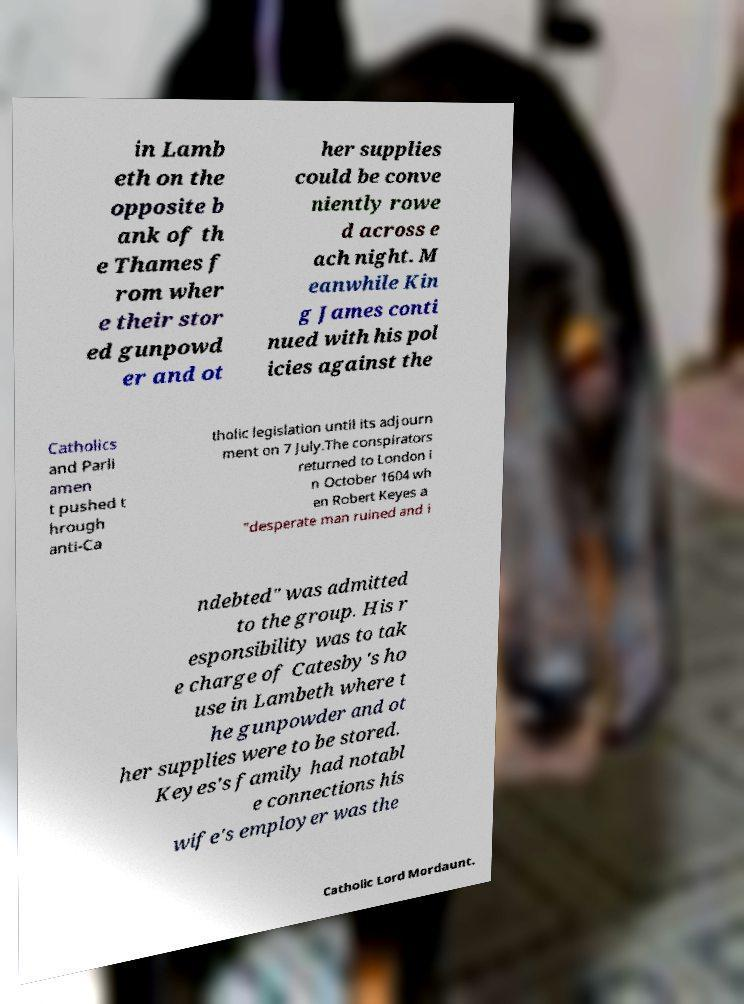I need the written content from this picture converted into text. Can you do that? in Lamb eth on the opposite b ank of th e Thames f rom wher e their stor ed gunpowd er and ot her supplies could be conve niently rowe d across e ach night. M eanwhile Kin g James conti nued with his pol icies against the Catholics and Parli amen t pushed t hrough anti-Ca tholic legislation until its adjourn ment on 7 July.The conspirators returned to London i n October 1604 wh en Robert Keyes a "desperate man ruined and i ndebted" was admitted to the group. His r esponsibility was to tak e charge of Catesby's ho use in Lambeth where t he gunpowder and ot her supplies were to be stored. Keyes's family had notabl e connections his wife's employer was the Catholic Lord Mordaunt. 